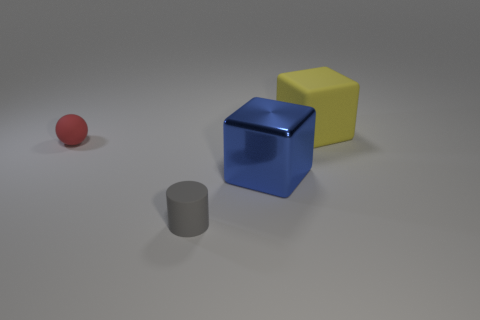Are there any other things that have the same material as the blue thing?
Your answer should be compact. No. What is the shape of the big object that is left of the big thing that is to the right of the big thing that is in front of the yellow object?
Your response must be concise. Cube. What number of gray things are either matte cubes or small matte spheres?
Keep it short and to the point. 0. Are there the same number of red objects that are in front of the gray matte cylinder and blue metal blocks that are to the right of the big blue cube?
Your answer should be very brief. Yes. There is a matte object that is in front of the big shiny cube; is its shape the same as the big thing that is in front of the tiny ball?
Your answer should be compact. No. Is there any other thing that has the same shape as the yellow rubber object?
Offer a very short reply. Yes. There is a yellow object that is made of the same material as the red thing; what is its shape?
Your response must be concise. Cube. Is the number of cubes that are to the right of the ball the same as the number of big rubber cubes?
Keep it short and to the point. No. Is the tiny red sphere that is behind the tiny cylinder made of the same material as the large object that is behind the small red rubber object?
Your answer should be compact. Yes. There is a tiny thing that is in front of the tiny rubber thing to the left of the gray matte cylinder; what is its shape?
Offer a terse response. Cylinder. 